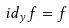<formula> <loc_0><loc_0><loc_500><loc_500>i d _ { y } f = f</formula> 